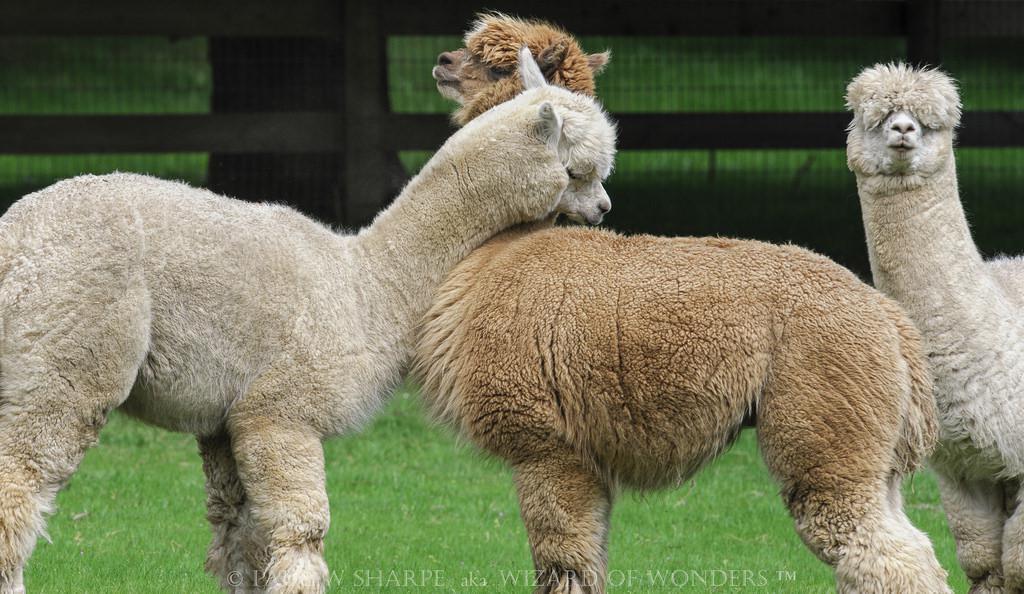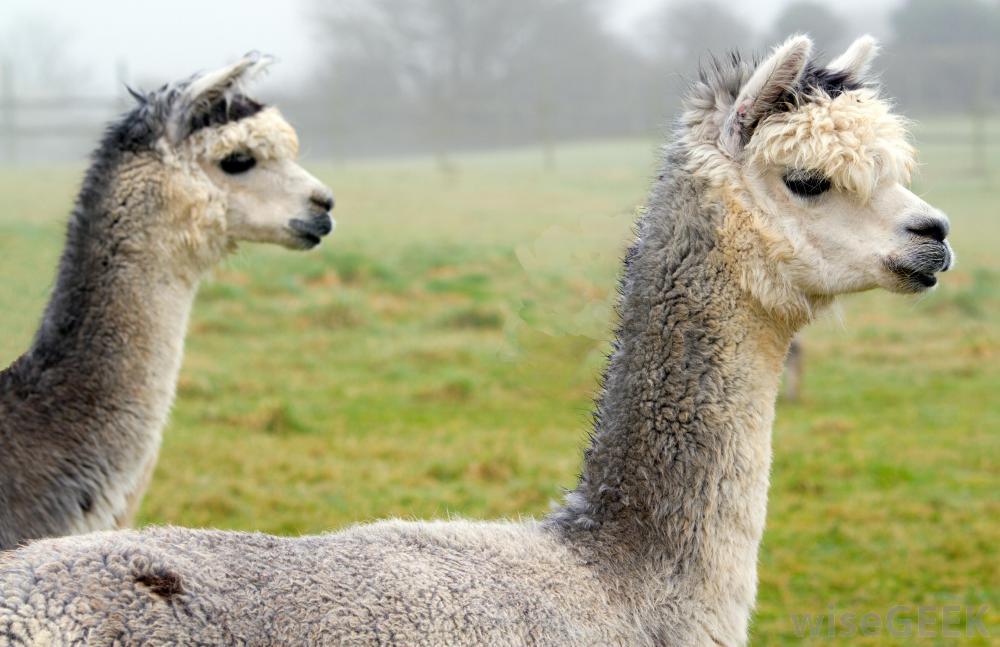The first image is the image on the left, the second image is the image on the right. For the images displayed, is the sentence "The left and right image contains the same number of alpacas." factually correct? Answer yes or no. No. The first image is the image on the left, the second image is the image on the right. Examine the images to the left and right. Is the description "Two white llamas of similar size are in a kissing pose in the right image." accurate? Answer yes or no. No. 